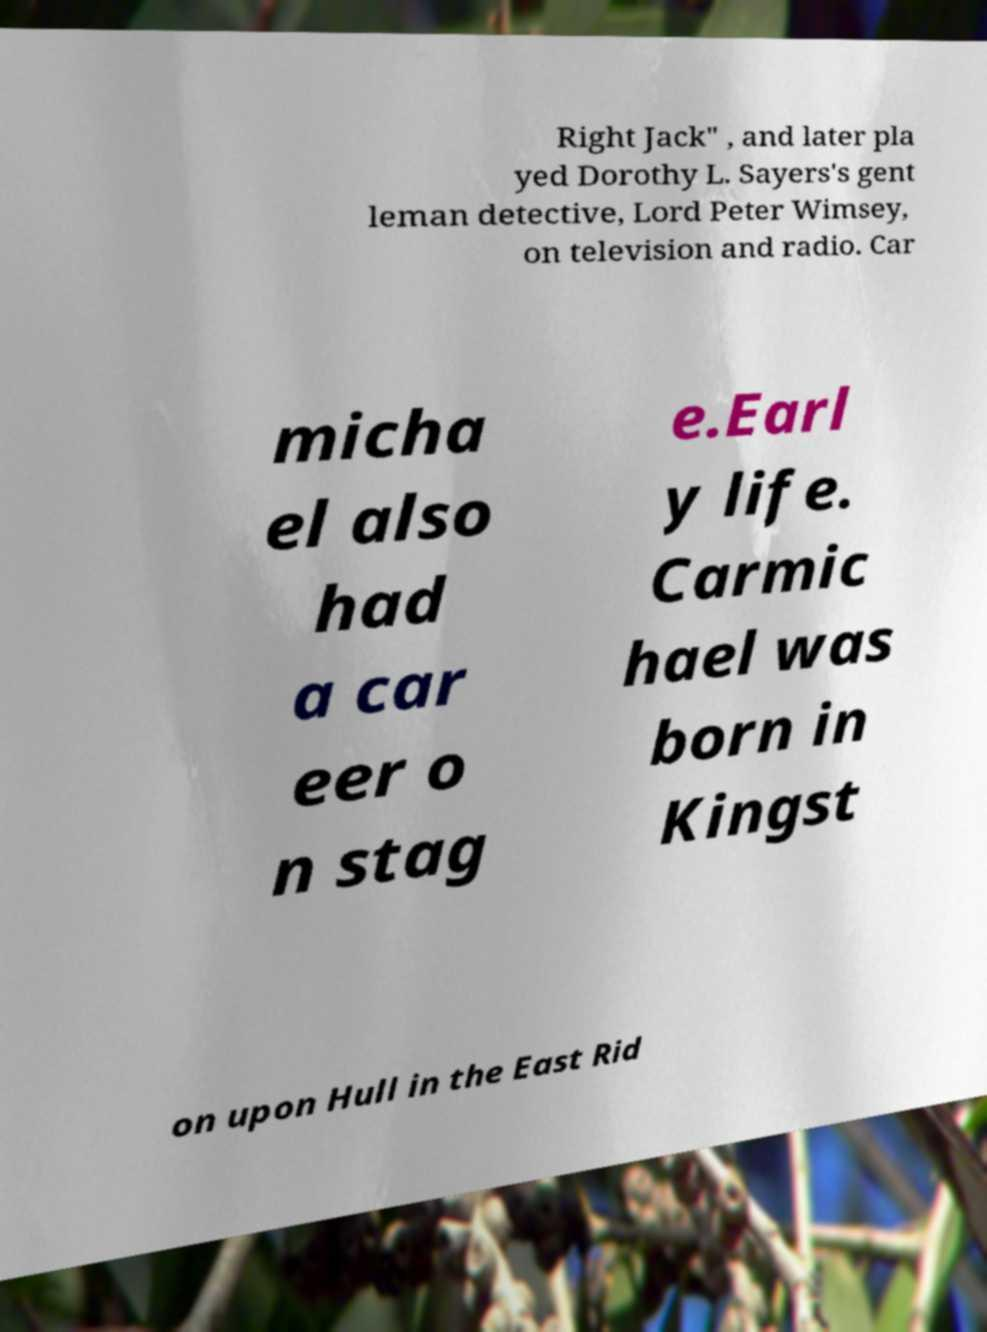Can you read and provide the text displayed in the image?This photo seems to have some interesting text. Can you extract and type it out for me? Right Jack" , and later pla yed Dorothy L. Sayers's gent leman detective, Lord Peter Wimsey, on television and radio. Car micha el also had a car eer o n stag e.Earl y life. Carmic hael was born in Kingst on upon Hull in the East Rid 